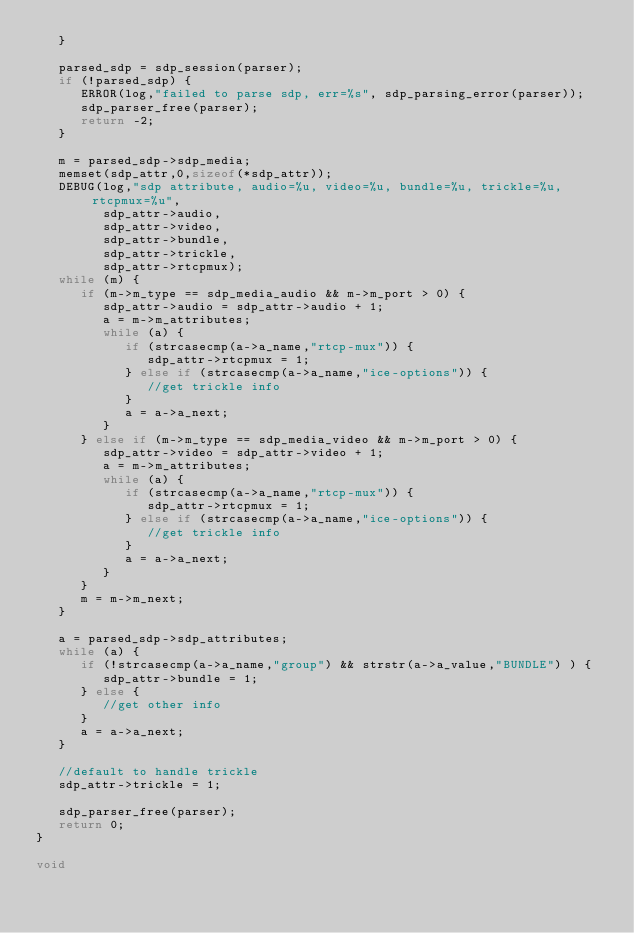Convert code to text. <code><loc_0><loc_0><loc_500><loc_500><_C_>   }

   parsed_sdp = sdp_session(parser);
   if (!parsed_sdp) {
      ERROR(log,"failed to parse sdp, err=%s", sdp_parsing_error(parser));
      sdp_parser_free(parser);
      return -2;
   } 

   m = parsed_sdp->sdp_media;
   memset(sdp_attr,0,sizeof(*sdp_attr));
   DEBUG(log,"sdp attribute, audio=%u, video=%u, bundle=%u, trickle=%u, rtcpmux=%u", 
         sdp_attr->audio, 
         sdp_attr->video, 
         sdp_attr->bundle, 
         sdp_attr->trickle,
         sdp_attr->rtcpmux);
   while (m) {
      if (m->m_type == sdp_media_audio && m->m_port > 0) {
         sdp_attr->audio = sdp_attr->audio + 1;
         a = m->m_attributes;
         while (a) {
            if (strcasecmp(a->a_name,"rtcp-mux")) {
               sdp_attr->rtcpmux = 1;
            } else if (strcasecmp(a->a_name,"ice-options")) {
               //get trickle info
            }
            a = a->a_next;
         }
      } else if (m->m_type == sdp_media_video && m->m_port > 0) {
         sdp_attr->video = sdp_attr->video + 1;
         a = m->m_attributes;
         while (a) {
            if (strcasecmp(a->a_name,"rtcp-mux")) {
               sdp_attr->rtcpmux = 1;
            } else if (strcasecmp(a->a_name,"ice-options")) {
               //get trickle info
            }
            a = a->a_next;
         }
      }
      m = m->m_next;
   }  

   a = parsed_sdp->sdp_attributes;
   while (a) {
      if (!strcasecmp(a->a_name,"group") && strstr(a->a_value,"BUNDLE") ) {
         sdp_attr->bundle = 1;
      } else {
         //get other info
      }
      a = a->a_next;
   }

   //default to handle trickle
   sdp_attr->trickle = 1;

   sdp_parser_free(parser);
   return 0;
}

void </code> 